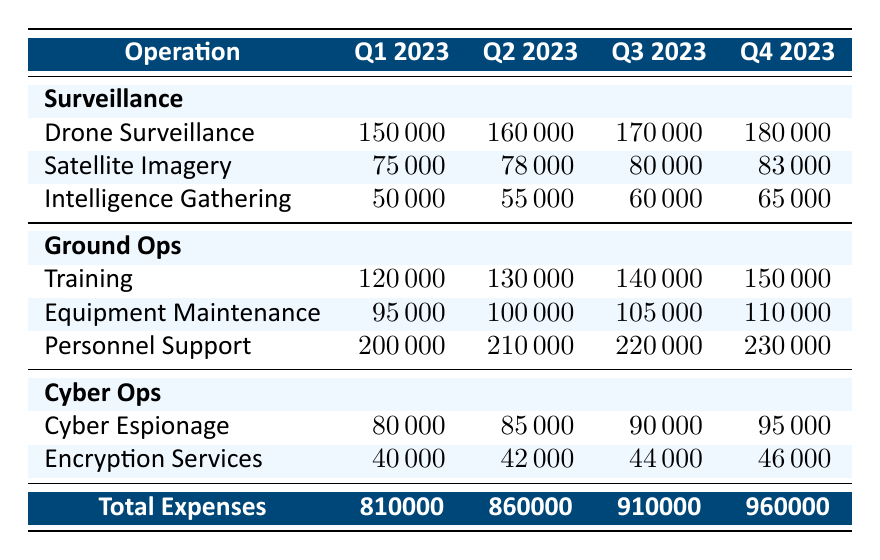What were the total expenses for Q3 2023? The total expenses for Q3 2023 can be directly found in the table under the "Total Expenses" row for that quarter. The value listed is 910000.
Answer: 910000 Which operation had the highest expenses in Q2 2023? We need to look at all the operations in Q2 2023 and identify the one with the highest value. In Q2 2023, Personnel Support in Ground Ops has the highest value at 210000.
Answer: Personnel Support What is the increase in total expenses from Q1 2023 to Q4 2023? To find the increase, subtract the total expenses of Q1 2023 from those of Q4 2023: 960000 (Q4) - 810000 (Q1) = 150000.
Answer: 150000 Is the total expenses for Q1 2023 greater than the total expenses for Q2 2023? We compare the total expenses for both quarters: 810000 (Q1) and 860000 (Q2). Since 810000 is less than 860000, the statement is false.
Answer: No What was the average spending on Cyber Ops across all quarters? We sum the expenses for Cyber Espionage and Encryption Services for each quarter and find the average. The total for Cyber Ops across the four quarters is (80000 + 40000 + 85000 + 42000 + 90000 + 44000 + 95000 + 46000) = 388000. There are 4 quarters, so the average is 388000 / 4 = 97000.
Answer: 97000 In which quarter did the spending on drone surveillance exceed 170000? Looking at the drone surveillance expenses: Q1 is 150000, Q2 is 160000, Q3 is 170000, and Q4 is 180000. Drone surveillance exceeded 170000 in Q4 2023.
Answer: Q4 2023 What is the total expense for personnel support across all four quarters? We will add the expenses for personnel support for each quarter: 200000 (Q1) + 210000 (Q2) + 220000 (Q3) + 230000 (Q4) = 860000.
Answer: 860000 Did total expenses increase from Q3 2023 to Q4 2023? We need to compare the total expenses for the two quarters: 910000 (Q3) and 960000 (Q4). Since 960000 is greater than 910000, we can conclude that expenses did increase.
Answer: Yes 